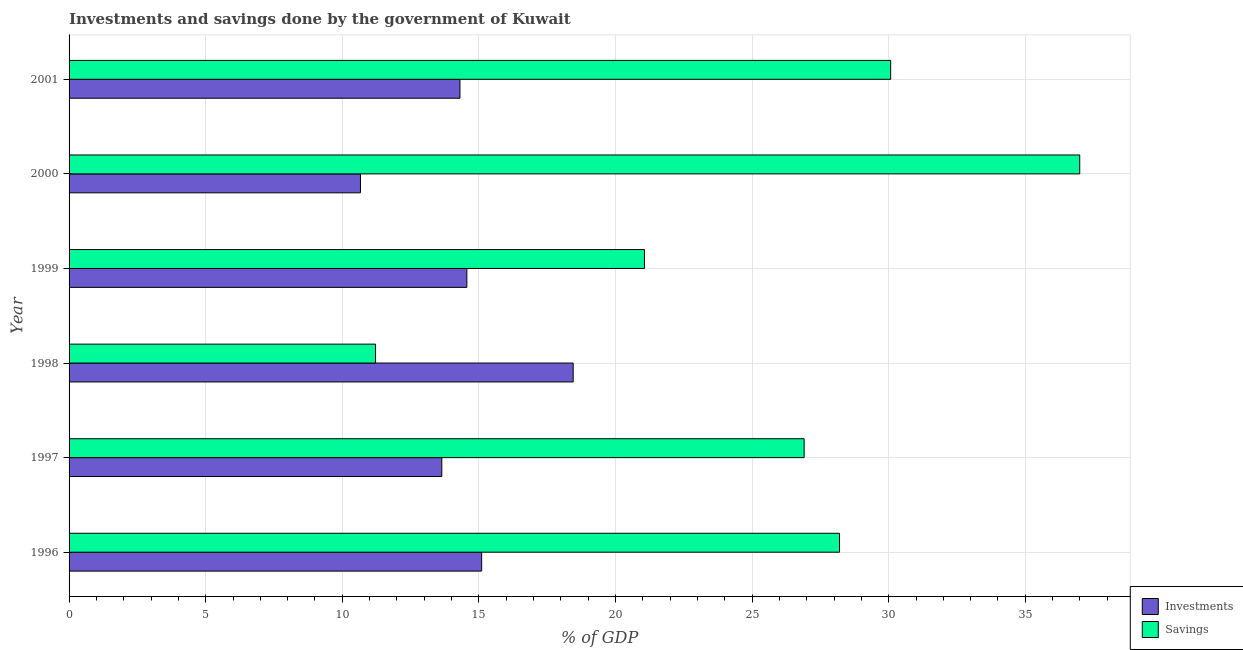How many different coloured bars are there?
Ensure brevity in your answer.  2. Are the number of bars per tick equal to the number of legend labels?
Provide a succinct answer. Yes. What is the label of the 3rd group of bars from the top?
Your answer should be compact. 1999. What is the savings of government in 1996?
Keep it short and to the point. 28.2. Across all years, what is the maximum investments of government?
Provide a succinct answer. 18.45. Across all years, what is the minimum savings of government?
Give a very brief answer. 11.22. In which year was the investments of government minimum?
Offer a very short reply. 2000. What is the total savings of government in the graph?
Your response must be concise. 154.45. What is the difference between the savings of government in 1996 and that in 2000?
Make the answer very short. -8.79. What is the difference between the investments of government in 2000 and the savings of government in 1999?
Provide a short and direct response. -10.39. What is the average investments of government per year?
Offer a terse response. 14.46. In the year 2000, what is the difference between the investments of government and savings of government?
Make the answer very short. -26.33. What is the ratio of the savings of government in 1998 to that in 1999?
Your answer should be compact. 0.53. What is the difference between the highest and the second highest savings of government?
Offer a very short reply. 6.92. What is the difference between the highest and the lowest savings of government?
Provide a succinct answer. 25.77. In how many years, is the investments of government greater than the average investments of government taken over all years?
Give a very brief answer. 3. What does the 2nd bar from the top in 2001 represents?
Give a very brief answer. Investments. What does the 2nd bar from the bottom in 1997 represents?
Provide a short and direct response. Savings. How many bars are there?
Offer a very short reply. 12. Are the values on the major ticks of X-axis written in scientific E-notation?
Make the answer very short. No. Does the graph contain any zero values?
Your response must be concise. No. Where does the legend appear in the graph?
Your answer should be compact. Bottom right. What is the title of the graph?
Ensure brevity in your answer.  Investments and savings done by the government of Kuwait. What is the label or title of the X-axis?
Offer a terse response. % of GDP. What is the label or title of the Y-axis?
Your answer should be very brief. Year. What is the % of GDP of Investments in 1996?
Provide a succinct answer. 15.1. What is the % of GDP in Savings in 1996?
Keep it short and to the point. 28.2. What is the % of GDP of Investments in 1997?
Your answer should be very brief. 13.64. What is the % of GDP in Savings in 1997?
Your answer should be compact. 26.9. What is the % of GDP of Investments in 1998?
Offer a very short reply. 18.45. What is the % of GDP in Savings in 1998?
Keep it short and to the point. 11.22. What is the % of GDP in Investments in 1999?
Ensure brevity in your answer.  14.56. What is the % of GDP in Savings in 1999?
Ensure brevity in your answer.  21.06. What is the % of GDP in Investments in 2000?
Provide a succinct answer. 10.67. What is the % of GDP of Savings in 2000?
Keep it short and to the point. 36.99. What is the % of GDP of Investments in 2001?
Offer a very short reply. 14.31. What is the % of GDP in Savings in 2001?
Keep it short and to the point. 30.07. Across all years, what is the maximum % of GDP of Investments?
Offer a very short reply. 18.45. Across all years, what is the maximum % of GDP of Savings?
Give a very brief answer. 36.99. Across all years, what is the minimum % of GDP of Investments?
Make the answer very short. 10.67. Across all years, what is the minimum % of GDP of Savings?
Give a very brief answer. 11.22. What is the total % of GDP of Investments in the graph?
Give a very brief answer. 86.73. What is the total % of GDP of Savings in the graph?
Provide a short and direct response. 154.45. What is the difference between the % of GDP in Investments in 1996 and that in 1997?
Keep it short and to the point. 1.46. What is the difference between the % of GDP of Savings in 1996 and that in 1997?
Offer a terse response. 1.29. What is the difference between the % of GDP of Investments in 1996 and that in 1998?
Keep it short and to the point. -3.35. What is the difference between the % of GDP of Savings in 1996 and that in 1998?
Offer a very short reply. 16.98. What is the difference between the % of GDP of Investments in 1996 and that in 1999?
Make the answer very short. 0.54. What is the difference between the % of GDP of Savings in 1996 and that in 1999?
Give a very brief answer. 7.14. What is the difference between the % of GDP of Investments in 1996 and that in 2000?
Keep it short and to the point. 4.44. What is the difference between the % of GDP in Savings in 1996 and that in 2000?
Make the answer very short. -8.79. What is the difference between the % of GDP in Investments in 1996 and that in 2001?
Offer a terse response. 0.79. What is the difference between the % of GDP in Savings in 1996 and that in 2001?
Provide a short and direct response. -1.87. What is the difference between the % of GDP of Investments in 1997 and that in 1998?
Your answer should be compact. -4.81. What is the difference between the % of GDP in Savings in 1997 and that in 1998?
Offer a terse response. 15.69. What is the difference between the % of GDP of Investments in 1997 and that in 1999?
Provide a short and direct response. -0.92. What is the difference between the % of GDP in Savings in 1997 and that in 1999?
Give a very brief answer. 5.84. What is the difference between the % of GDP in Investments in 1997 and that in 2000?
Offer a terse response. 2.98. What is the difference between the % of GDP in Savings in 1997 and that in 2000?
Your answer should be very brief. -10.09. What is the difference between the % of GDP in Investments in 1997 and that in 2001?
Provide a succinct answer. -0.66. What is the difference between the % of GDP of Savings in 1997 and that in 2001?
Provide a succinct answer. -3.17. What is the difference between the % of GDP of Investments in 1998 and that in 1999?
Keep it short and to the point. 3.89. What is the difference between the % of GDP of Savings in 1998 and that in 1999?
Provide a succinct answer. -9.84. What is the difference between the % of GDP of Investments in 1998 and that in 2000?
Your response must be concise. 7.79. What is the difference between the % of GDP in Savings in 1998 and that in 2000?
Ensure brevity in your answer.  -25.77. What is the difference between the % of GDP of Investments in 1998 and that in 2001?
Make the answer very short. 4.14. What is the difference between the % of GDP in Savings in 1998 and that in 2001?
Your response must be concise. -18.85. What is the difference between the % of GDP in Investments in 1999 and that in 2000?
Make the answer very short. 3.89. What is the difference between the % of GDP in Savings in 1999 and that in 2000?
Keep it short and to the point. -15.93. What is the difference between the % of GDP in Investments in 1999 and that in 2001?
Keep it short and to the point. 0.25. What is the difference between the % of GDP in Savings in 1999 and that in 2001?
Give a very brief answer. -9.01. What is the difference between the % of GDP of Investments in 2000 and that in 2001?
Ensure brevity in your answer.  -3.64. What is the difference between the % of GDP of Savings in 2000 and that in 2001?
Your response must be concise. 6.92. What is the difference between the % of GDP in Investments in 1996 and the % of GDP in Savings in 1997?
Offer a very short reply. -11.8. What is the difference between the % of GDP in Investments in 1996 and the % of GDP in Savings in 1998?
Ensure brevity in your answer.  3.88. What is the difference between the % of GDP of Investments in 1996 and the % of GDP of Savings in 1999?
Make the answer very short. -5.96. What is the difference between the % of GDP of Investments in 1996 and the % of GDP of Savings in 2000?
Offer a very short reply. -21.89. What is the difference between the % of GDP of Investments in 1996 and the % of GDP of Savings in 2001?
Your answer should be very brief. -14.97. What is the difference between the % of GDP in Investments in 1997 and the % of GDP in Savings in 1998?
Give a very brief answer. 2.42. What is the difference between the % of GDP of Investments in 1997 and the % of GDP of Savings in 1999?
Your answer should be compact. -7.42. What is the difference between the % of GDP in Investments in 1997 and the % of GDP in Savings in 2000?
Your answer should be very brief. -23.35. What is the difference between the % of GDP in Investments in 1997 and the % of GDP in Savings in 2001?
Provide a succinct answer. -16.43. What is the difference between the % of GDP of Investments in 1998 and the % of GDP of Savings in 1999?
Your answer should be very brief. -2.61. What is the difference between the % of GDP in Investments in 1998 and the % of GDP in Savings in 2000?
Give a very brief answer. -18.54. What is the difference between the % of GDP in Investments in 1998 and the % of GDP in Savings in 2001?
Provide a succinct answer. -11.62. What is the difference between the % of GDP of Investments in 1999 and the % of GDP of Savings in 2000?
Give a very brief answer. -22.43. What is the difference between the % of GDP of Investments in 1999 and the % of GDP of Savings in 2001?
Give a very brief answer. -15.51. What is the difference between the % of GDP of Investments in 2000 and the % of GDP of Savings in 2001?
Your response must be concise. -19.41. What is the average % of GDP in Investments per year?
Your answer should be very brief. 14.45. What is the average % of GDP of Savings per year?
Your answer should be very brief. 25.74. In the year 1996, what is the difference between the % of GDP in Investments and % of GDP in Savings?
Your answer should be very brief. -13.1. In the year 1997, what is the difference between the % of GDP of Investments and % of GDP of Savings?
Your response must be concise. -13.26. In the year 1998, what is the difference between the % of GDP in Investments and % of GDP in Savings?
Offer a very short reply. 7.23. In the year 1999, what is the difference between the % of GDP of Investments and % of GDP of Savings?
Provide a short and direct response. -6.5. In the year 2000, what is the difference between the % of GDP in Investments and % of GDP in Savings?
Your answer should be very brief. -26.33. In the year 2001, what is the difference between the % of GDP in Investments and % of GDP in Savings?
Offer a very short reply. -15.76. What is the ratio of the % of GDP of Investments in 1996 to that in 1997?
Give a very brief answer. 1.11. What is the ratio of the % of GDP in Savings in 1996 to that in 1997?
Offer a terse response. 1.05. What is the ratio of the % of GDP in Investments in 1996 to that in 1998?
Your response must be concise. 0.82. What is the ratio of the % of GDP in Savings in 1996 to that in 1998?
Offer a very short reply. 2.51. What is the ratio of the % of GDP in Investments in 1996 to that in 1999?
Make the answer very short. 1.04. What is the ratio of the % of GDP of Savings in 1996 to that in 1999?
Provide a succinct answer. 1.34. What is the ratio of the % of GDP in Investments in 1996 to that in 2000?
Provide a succinct answer. 1.42. What is the ratio of the % of GDP of Savings in 1996 to that in 2000?
Keep it short and to the point. 0.76. What is the ratio of the % of GDP of Investments in 1996 to that in 2001?
Your answer should be compact. 1.06. What is the ratio of the % of GDP of Savings in 1996 to that in 2001?
Provide a short and direct response. 0.94. What is the ratio of the % of GDP in Investments in 1997 to that in 1998?
Your answer should be compact. 0.74. What is the ratio of the % of GDP in Savings in 1997 to that in 1998?
Your answer should be very brief. 2.4. What is the ratio of the % of GDP of Investments in 1997 to that in 1999?
Provide a short and direct response. 0.94. What is the ratio of the % of GDP in Savings in 1997 to that in 1999?
Provide a succinct answer. 1.28. What is the ratio of the % of GDP in Investments in 1997 to that in 2000?
Your answer should be compact. 1.28. What is the ratio of the % of GDP of Savings in 1997 to that in 2000?
Provide a short and direct response. 0.73. What is the ratio of the % of GDP in Investments in 1997 to that in 2001?
Provide a succinct answer. 0.95. What is the ratio of the % of GDP of Savings in 1997 to that in 2001?
Your response must be concise. 0.89. What is the ratio of the % of GDP in Investments in 1998 to that in 1999?
Offer a very short reply. 1.27. What is the ratio of the % of GDP of Savings in 1998 to that in 1999?
Your answer should be compact. 0.53. What is the ratio of the % of GDP in Investments in 1998 to that in 2000?
Keep it short and to the point. 1.73. What is the ratio of the % of GDP of Savings in 1998 to that in 2000?
Your answer should be compact. 0.3. What is the ratio of the % of GDP in Investments in 1998 to that in 2001?
Keep it short and to the point. 1.29. What is the ratio of the % of GDP in Savings in 1998 to that in 2001?
Make the answer very short. 0.37. What is the ratio of the % of GDP of Investments in 1999 to that in 2000?
Provide a short and direct response. 1.37. What is the ratio of the % of GDP in Savings in 1999 to that in 2000?
Offer a very short reply. 0.57. What is the ratio of the % of GDP in Investments in 1999 to that in 2001?
Offer a terse response. 1.02. What is the ratio of the % of GDP of Savings in 1999 to that in 2001?
Ensure brevity in your answer.  0.7. What is the ratio of the % of GDP in Investments in 2000 to that in 2001?
Keep it short and to the point. 0.75. What is the ratio of the % of GDP of Savings in 2000 to that in 2001?
Your answer should be compact. 1.23. What is the difference between the highest and the second highest % of GDP in Investments?
Give a very brief answer. 3.35. What is the difference between the highest and the second highest % of GDP of Savings?
Your answer should be very brief. 6.92. What is the difference between the highest and the lowest % of GDP in Investments?
Provide a succinct answer. 7.79. What is the difference between the highest and the lowest % of GDP of Savings?
Offer a very short reply. 25.77. 